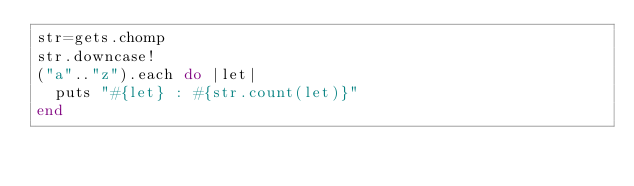<code> <loc_0><loc_0><loc_500><loc_500><_Ruby_>str=gets.chomp
str.downcase!
("a".."z").each do |let|
  puts "#{let} : #{str.count(let)}"
end</code> 